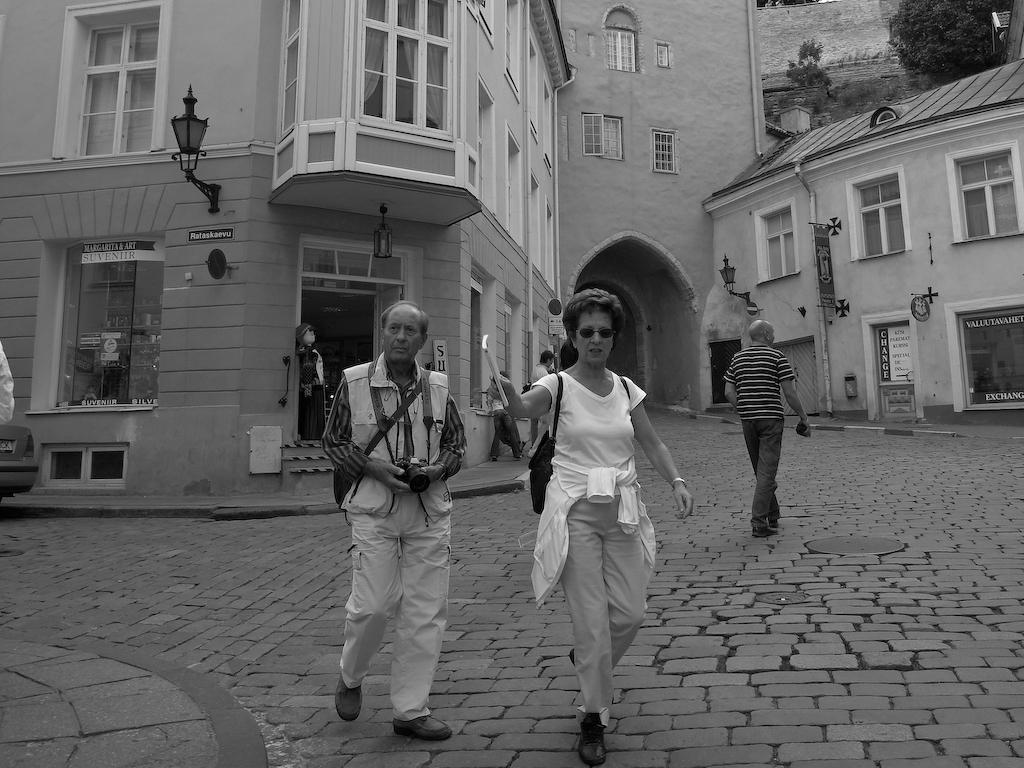What can be seen on the ground in the image? There are people on the ground in the image. What type of lighting is present in the image? There are lamps in the image. What type of decorations are visible in the image? There are posters in the image. What type of vegetation is present in the image? There are trees in the image. What type of objects are present in the image? There are objects in the image. What type of structures can be seen in the background of the image? There are buildings with windows in the background of the image. What color is the silver bursting from the heat in the image? There is no silver, bursting, or heat present in the image. 